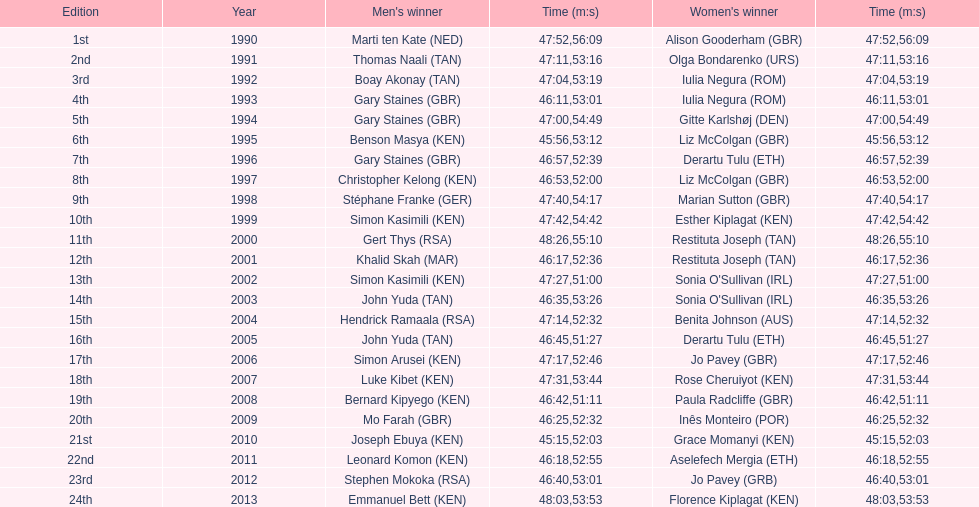Quantity of male winners with an end time under 46:58 12. 